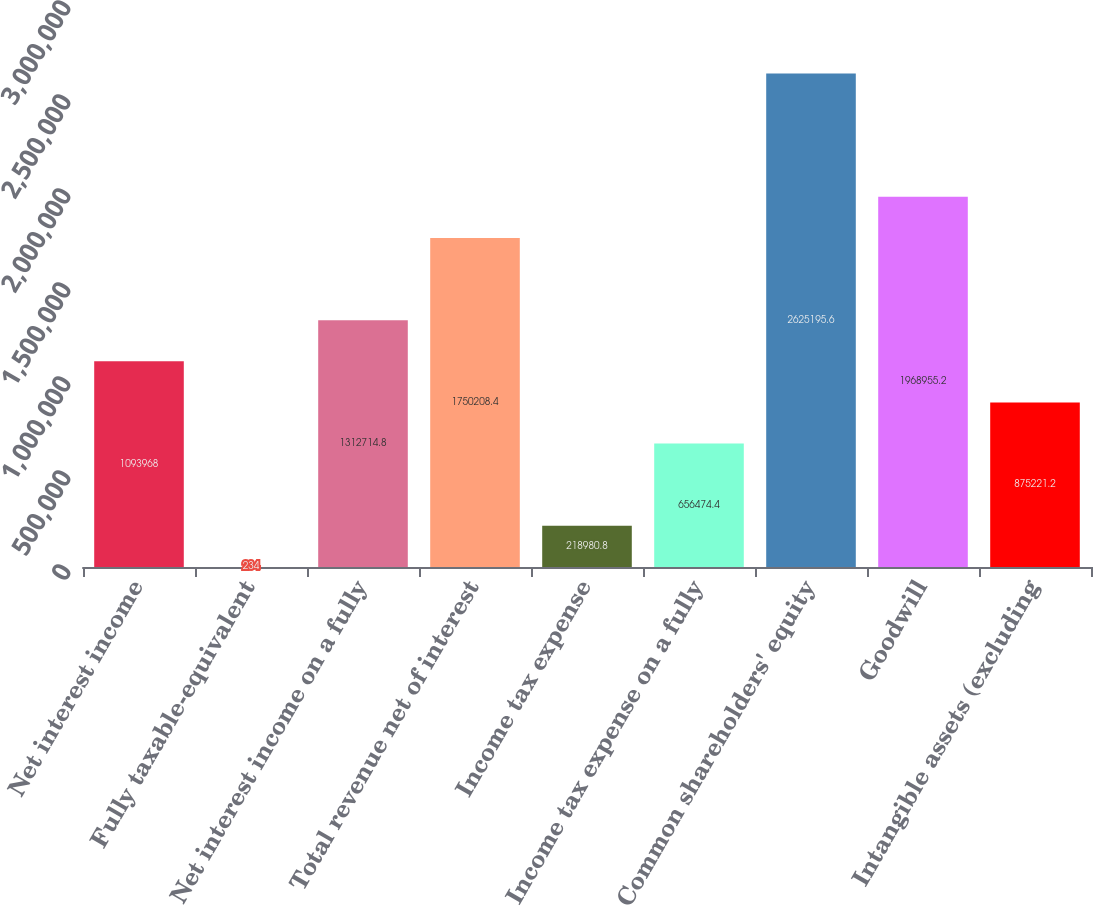Convert chart to OTSL. <chart><loc_0><loc_0><loc_500><loc_500><bar_chart><fcel>Net interest income<fcel>Fully taxable-equivalent<fcel>Net interest income on a fully<fcel>Total revenue net of interest<fcel>Income tax expense<fcel>Income tax expense on a fully<fcel>Common shareholders' equity<fcel>Goodwill<fcel>Intangible assets (excluding<nl><fcel>1.09397e+06<fcel>234<fcel>1.31271e+06<fcel>1.75021e+06<fcel>218981<fcel>656474<fcel>2.6252e+06<fcel>1.96896e+06<fcel>875221<nl></chart> 